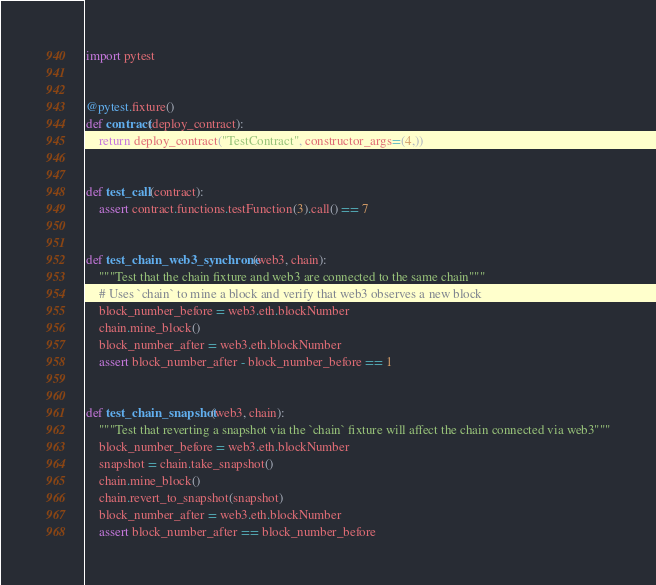<code> <loc_0><loc_0><loc_500><loc_500><_Python_>import pytest


@pytest.fixture()
def contract(deploy_contract):
    return deploy_contract("TestContract", constructor_args=(4,))


def test_call(contract):
    assert contract.functions.testFunction(3).call() == 7


def test_chain_web3_synchrone(web3, chain):
    """Test that the chain fixture and web3 are connected to the same chain"""
    # Uses `chain` to mine a block and verify that web3 observes a new block
    block_number_before = web3.eth.blockNumber
    chain.mine_block()
    block_number_after = web3.eth.blockNumber
    assert block_number_after - block_number_before == 1


def test_chain_snapshot(web3, chain):
    """Test that reverting a snapshot via the `chain` fixture will affect the chain connected via web3"""
    block_number_before = web3.eth.blockNumber
    snapshot = chain.take_snapshot()
    chain.mine_block()
    chain.revert_to_snapshot(snapshot)
    block_number_after = web3.eth.blockNumber
    assert block_number_after == block_number_before
</code> 